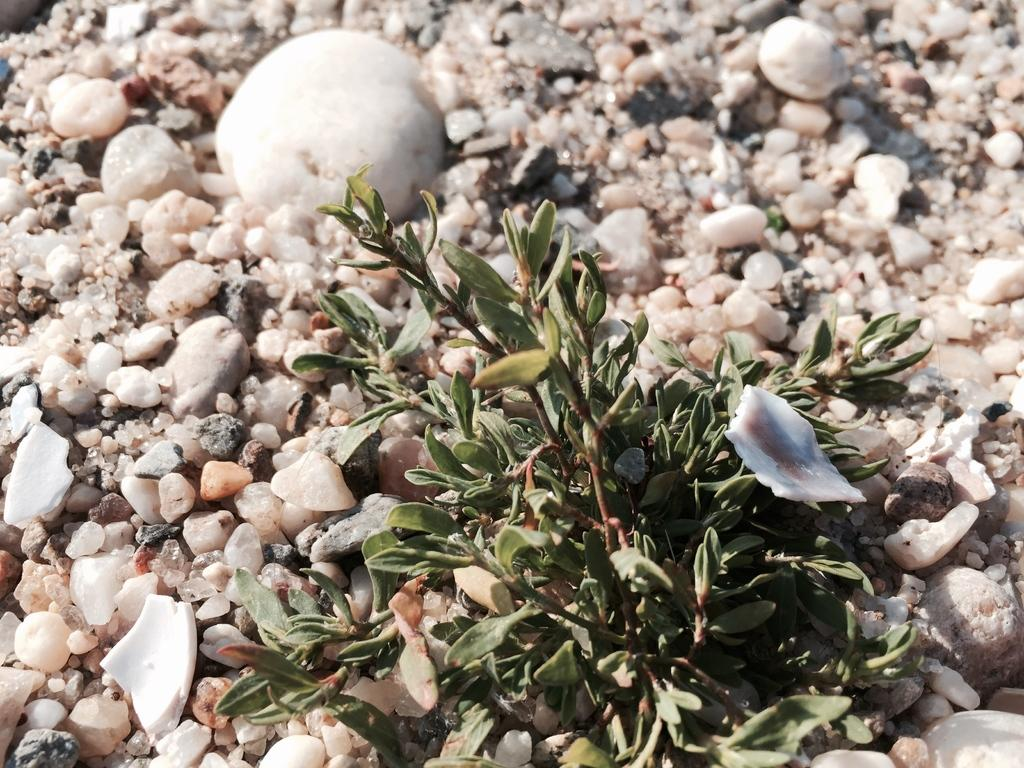What type of natural formation can be seen in the image? There are rocks in the image. What colors are the rocks in the image? The rocks are in white and cream color. What type of vegetation is present in the image? There is a plant in the image. What color is the plant in the image? The plant is in green color. How many times does the plant sneeze in the image? Plants do not sneeze, so this question cannot be answered. 